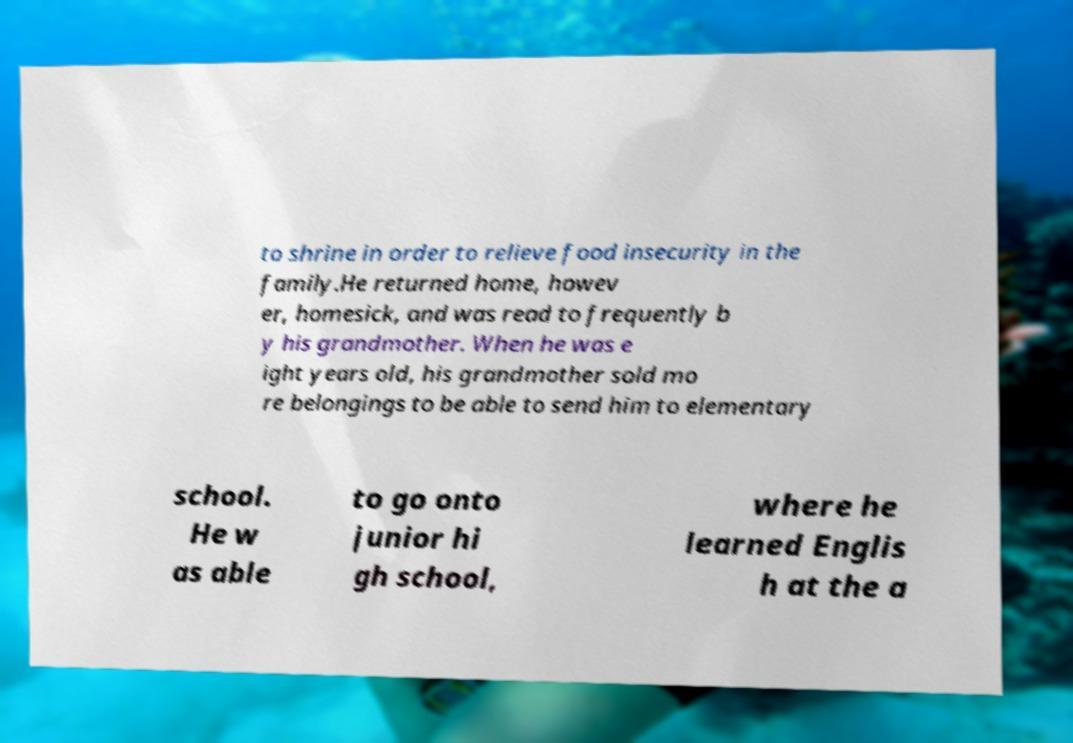There's text embedded in this image that I need extracted. Can you transcribe it verbatim? to shrine in order to relieve food insecurity in the family.He returned home, howev er, homesick, and was read to frequently b y his grandmother. When he was e ight years old, his grandmother sold mo re belongings to be able to send him to elementary school. He w as able to go onto junior hi gh school, where he learned Englis h at the a 